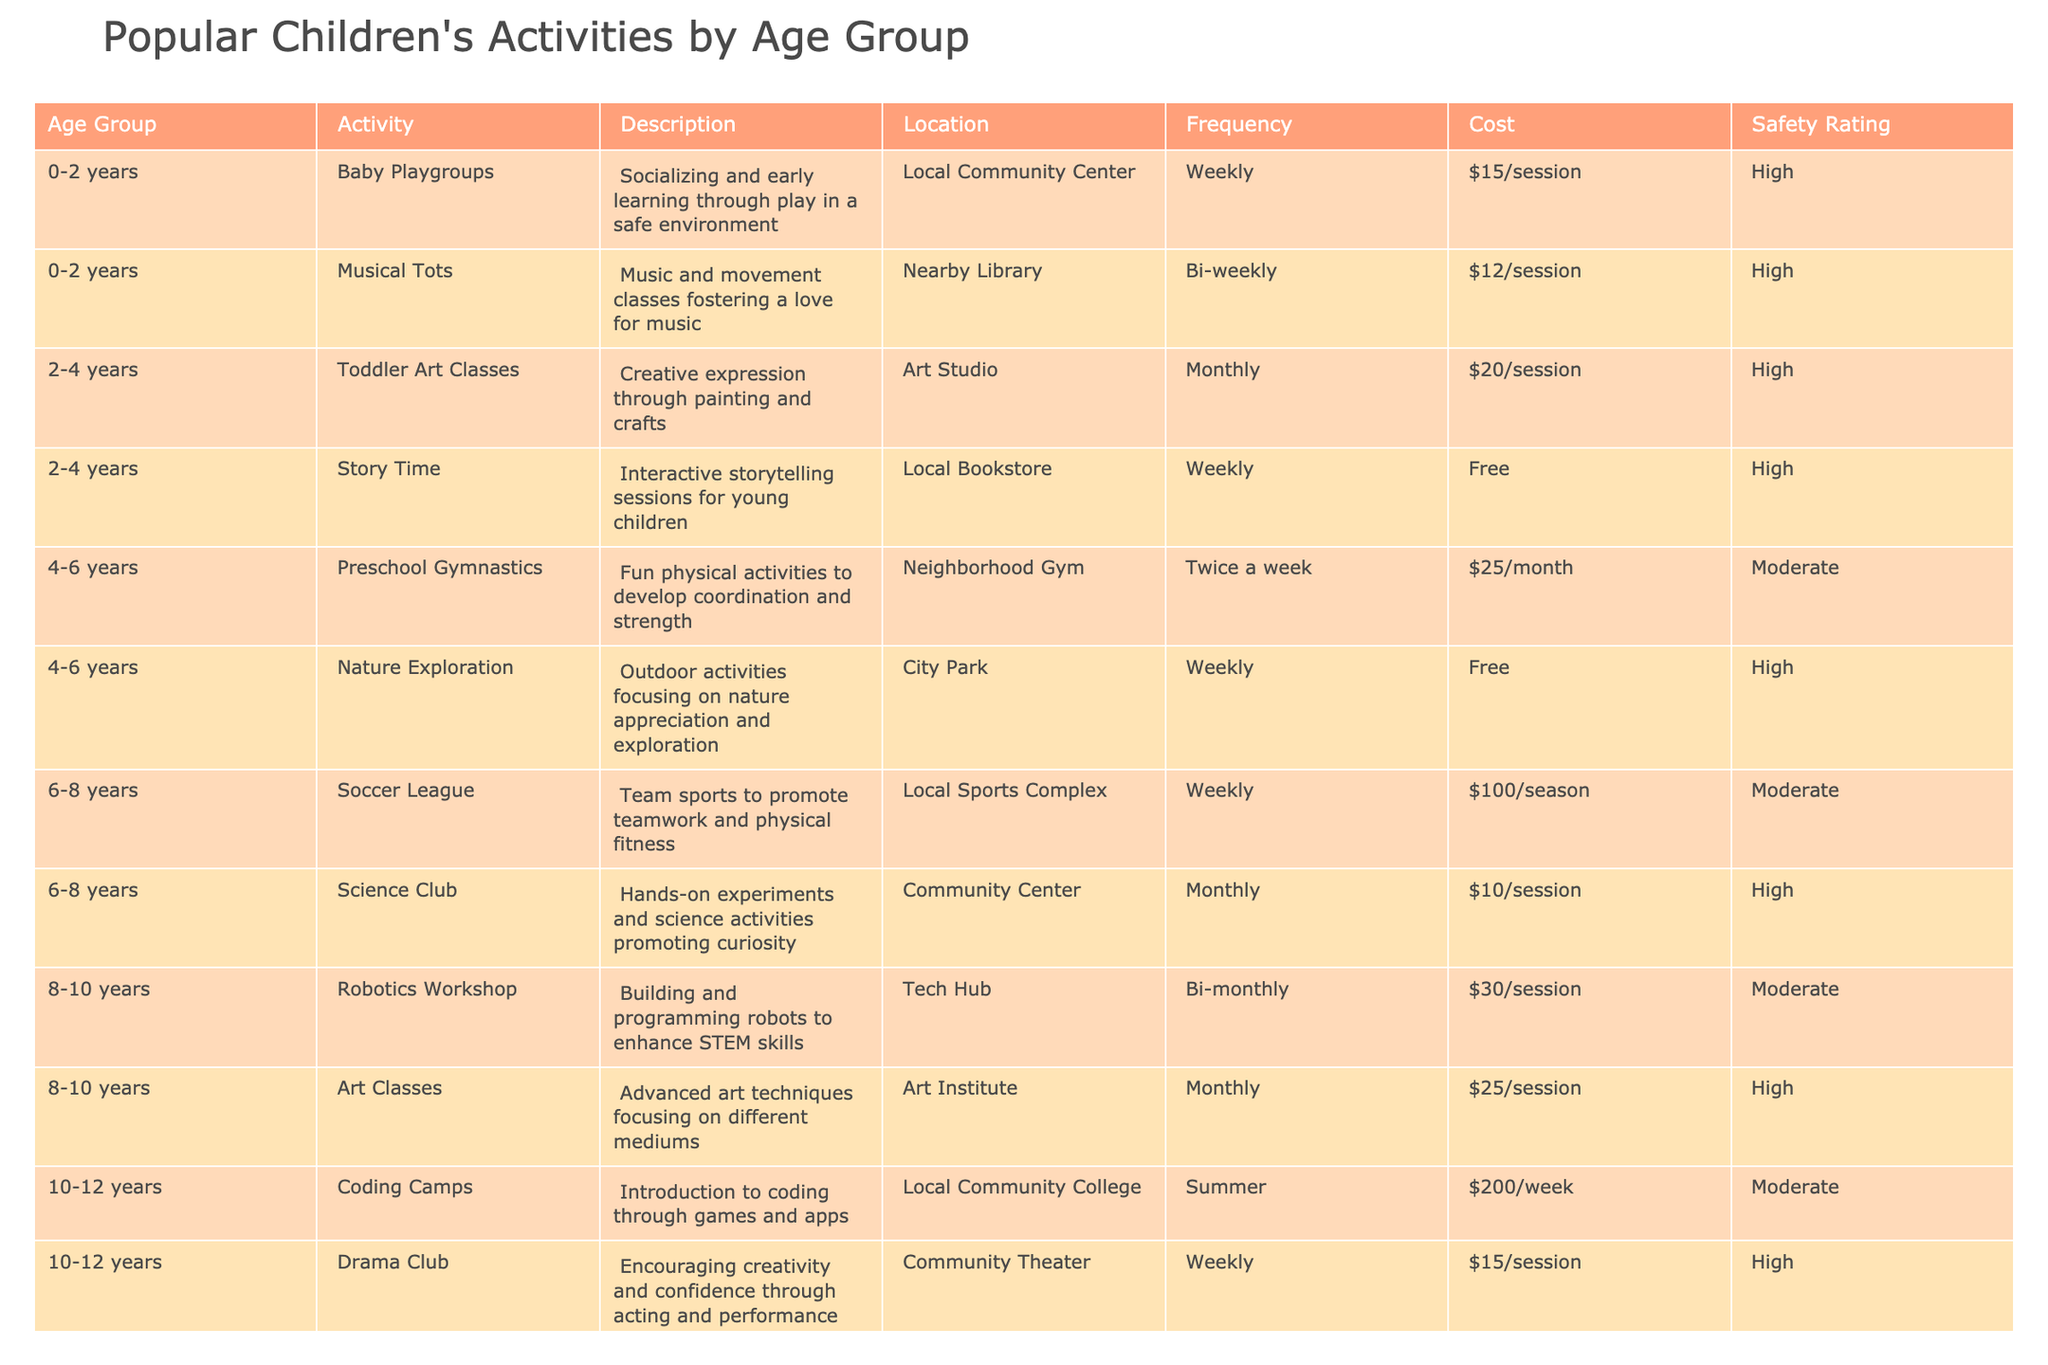What is the cost of attending a Baby Playgroup? The cost for attending a Baby Playgroup is listed in the Cost column next to the activity, which shows $15/session.
Answer: $15/session How often are Musical Tots classes offered? According to the Frequency column, Musical Tots classes are offered bi-weekly.
Answer: Bi-weekly Which activity has the highest Safety Rating in the 8-10 years age group? By reviewing the Safety Rating for activities in the 8-10 years category, both Robotics Workshop and Art Classes are rated High. Thus, they share the highest rating.
Answer: Robotics Workshop and Art Classes Is there an activity in the 2-4 years age group that is free? The Story Time activity in the 2-4 years age group is indicated as Free in the Cost column. Therefore, the answer is yes.
Answer: Yes What is the total cost for attending the Soccer League for one season? The Soccer League costs $100 per season, and as it is a single season fee, the total cost is simply $100 for that period.
Answer: $100 What is the frequency of Coding Camps during the summer? The Frequency column specifies that Coding Camps occur weekly during the summer, as stated for the 10-12 years age group activity.
Answer: Weekly Which two activities in the 14-16 years age group are listed as free? According to the Cost column, Volunteer Programs and Music Lessons are noted, but only Volunteer Programs are free. Hence, there is only one free activity.
Answer: One free activity: Volunteer Programs How many total paid activities are there for the 4-6 years age group? The paid activities for the 4-6 years age group are Preschool Gymnastics (cost $25/month), resulting in one paid activity, while Nature Exploration is free. Thus, there is only one paid activity.
Answer: One paid activity What is the average cost of the activities in the 12-14 years age group? To find the average, sum the costs of Skateboarding Lessons ($20/session) and Basketball League ($100/season). The total cost is $120. Since there are two activities, divide by 2: $120 / 2 = $60.
Answer: $60 